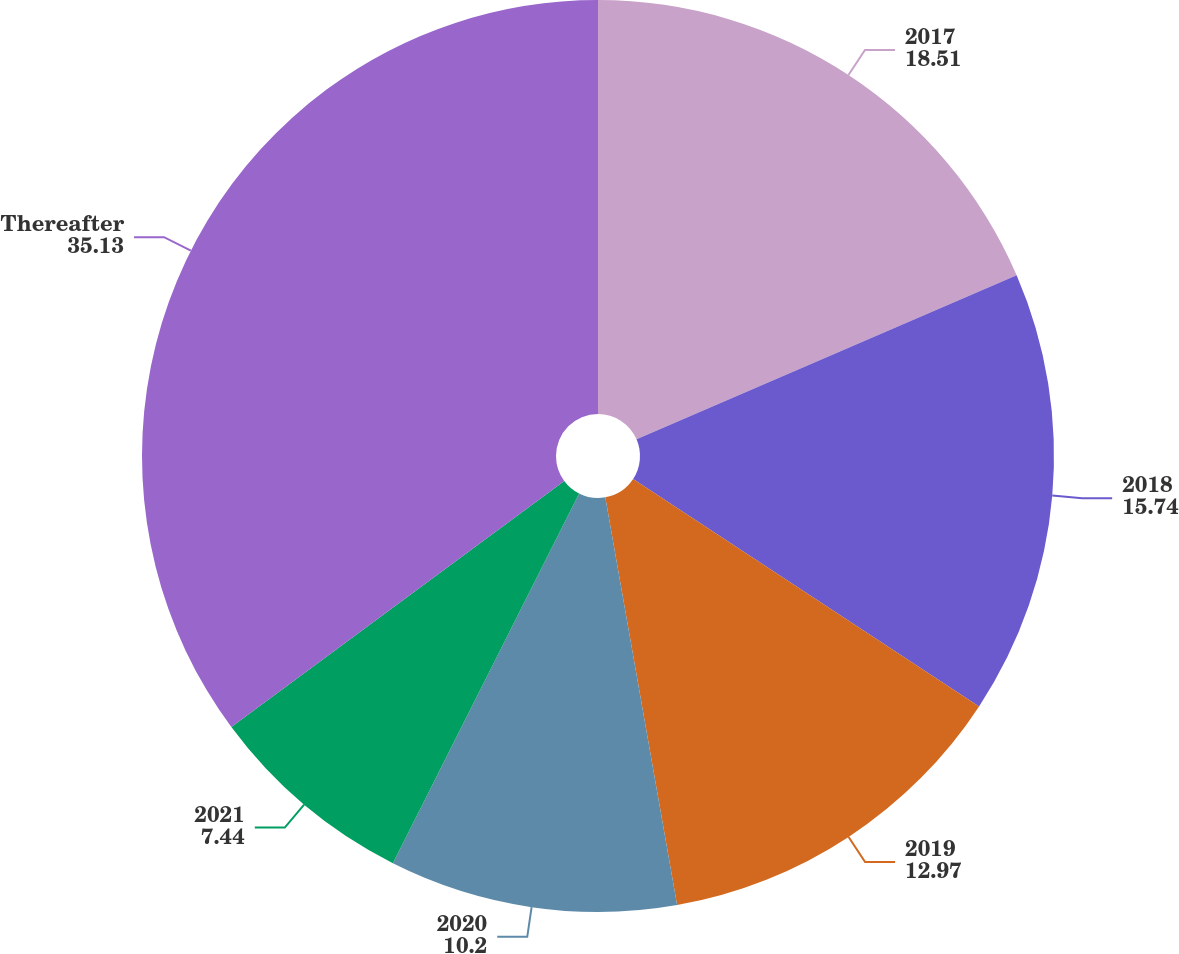<chart> <loc_0><loc_0><loc_500><loc_500><pie_chart><fcel>2017<fcel>2018<fcel>2019<fcel>2020<fcel>2021<fcel>Thereafter<nl><fcel>18.51%<fcel>15.74%<fcel>12.97%<fcel>10.2%<fcel>7.44%<fcel>35.13%<nl></chart> 